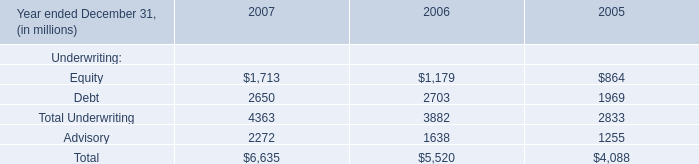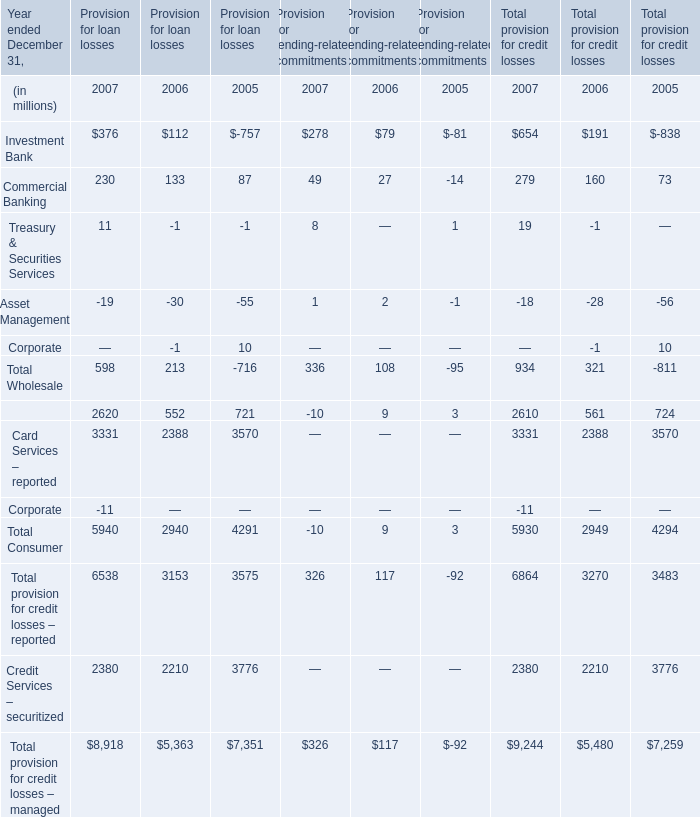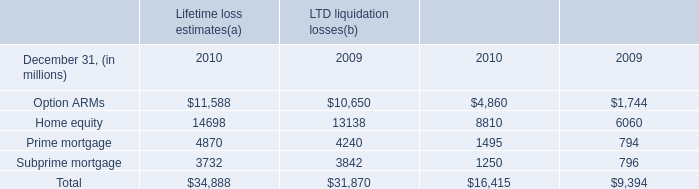in the consumer loan business , what percent of the adjustable rate borrowers weren't making any principal payments? 
Computations: (56 + 5)
Answer: 61.0. 